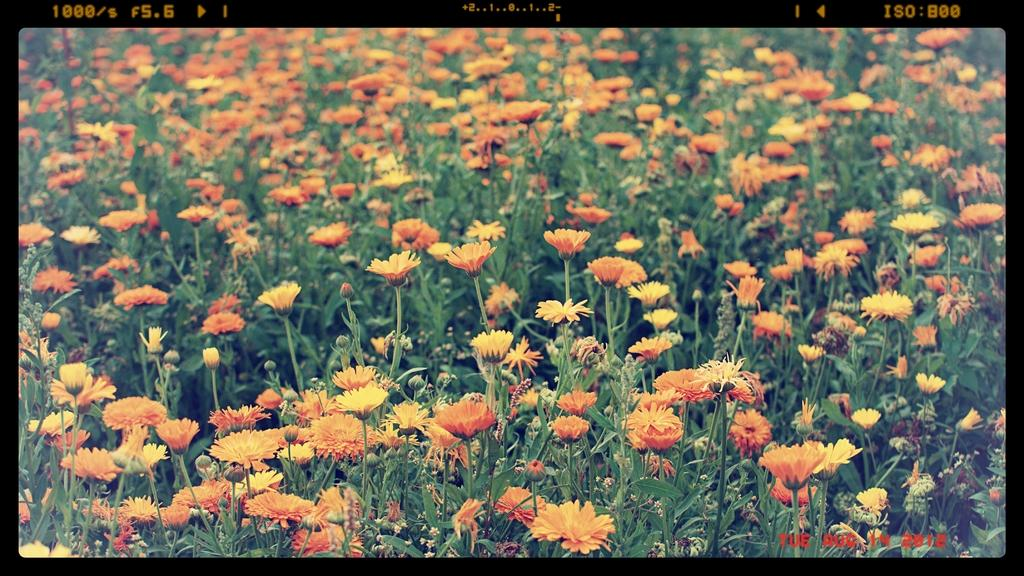What type of plants can be seen in the image? There is a group of plants with flowers in the image. What other elements are present in the image besides the plants? There are numbers visible at the top of the image and text in the bottom right corner of the image. What type of prison is depicted in the image? There is no prison present in the image; it features a group of plants with flowers, numbers, and text. How does the heat affect the flowers in the image? The image does not provide information about the temperature or heat, so it cannot be determined how it affects the flowers. 